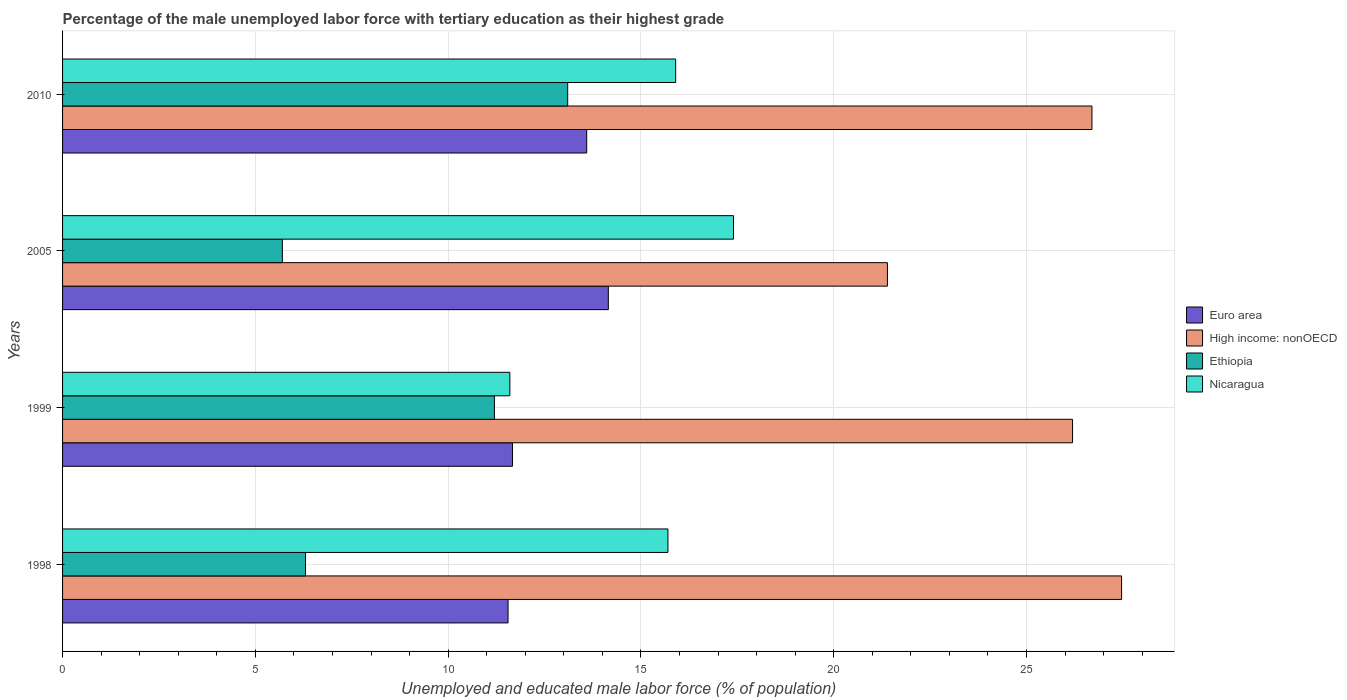How many different coloured bars are there?
Provide a succinct answer. 4. How many groups of bars are there?
Make the answer very short. 4. Are the number of bars per tick equal to the number of legend labels?
Your answer should be very brief. Yes. How many bars are there on the 1st tick from the top?
Provide a succinct answer. 4. In how many cases, is the number of bars for a given year not equal to the number of legend labels?
Offer a terse response. 0. What is the percentage of the unemployed male labor force with tertiary education in Euro area in 2010?
Your answer should be compact. 13.59. Across all years, what is the maximum percentage of the unemployed male labor force with tertiary education in Nicaragua?
Make the answer very short. 17.4. Across all years, what is the minimum percentage of the unemployed male labor force with tertiary education in Euro area?
Offer a very short reply. 11.55. In which year was the percentage of the unemployed male labor force with tertiary education in Ethiopia minimum?
Your answer should be very brief. 2005. What is the total percentage of the unemployed male labor force with tertiary education in High income: nonOECD in the graph?
Keep it short and to the point. 101.75. What is the difference between the percentage of the unemployed male labor force with tertiary education in Nicaragua in 1998 and that in 2010?
Ensure brevity in your answer.  -0.2. What is the difference between the percentage of the unemployed male labor force with tertiary education in High income: nonOECD in 1998 and the percentage of the unemployed male labor force with tertiary education in Euro area in 1999?
Your answer should be compact. 15.8. What is the average percentage of the unemployed male labor force with tertiary education in Euro area per year?
Your response must be concise. 12.74. In the year 1999, what is the difference between the percentage of the unemployed male labor force with tertiary education in Euro area and percentage of the unemployed male labor force with tertiary education in Nicaragua?
Keep it short and to the point. 0.07. What is the ratio of the percentage of the unemployed male labor force with tertiary education in Nicaragua in 1998 to that in 2010?
Offer a very short reply. 0.99. Is the difference between the percentage of the unemployed male labor force with tertiary education in Euro area in 1998 and 2005 greater than the difference between the percentage of the unemployed male labor force with tertiary education in Nicaragua in 1998 and 2005?
Your answer should be compact. No. What is the difference between the highest and the second highest percentage of the unemployed male labor force with tertiary education in Euro area?
Ensure brevity in your answer.  0.56. What is the difference between the highest and the lowest percentage of the unemployed male labor force with tertiary education in High income: nonOECD?
Ensure brevity in your answer.  6.07. In how many years, is the percentage of the unemployed male labor force with tertiary education in Nicaragua greater than the average percentage of the unemployed male labor force with tertiary education in Nicaragua taken over all years?
Your answer should be very brief. 3. Is the sum of the percentage of the unemployed male labor force with tertiary education in Euro area in 1998 and 2010 greater than the maximum percentage of the unemployed male labor force with tertiary education in High income: nonOECD across all years?
Your response must be concise. No. Is it the case that in every year, the sum of the percentage of the unemployed male labor force with tertiary education in Nicaragua and percentage of the unemployed male labor force with tertiary education in Euro area is greater than the sum of percentage of the unemployed male labor force with tertiary education in Ethiopia and percentage of the unemployed male labor force with tertiary education in High income: nonOECD?
Your response must be concise. No. What does the 1st bar from the top in 1999 represents?
Provide a succinct answer. Nicaragua. How many years are there in the graph?
Your answer should be very brief. 4. What is the difference between two consecutive major ticks on the X-axis?
Provide a short and direct response. 5. Are the values on the major ticks of X-axis written in scientific E-notation?
Make the answer very short. No. Does the graph contain any zero values?
Your answer should be compact. No. How are the legend labels stacked?
Offer a terse response. Vertical. What is the title of the graph?
Your response must be concise. Percentage of the male unemployed labor force with tertiary education as their highest grade. What is the label or title of the X-axis?
Your response must be concise. Unemployed and educated male labor force (% of population). What is the label or title of the Y-axis?
Your response must be concise. Years. What is the Unemployed and educated male labor force (% of population) of Euro area in 1998?
Offer a very short reply. 11.55. What is the Unemployed and educated male labor force (% of population) of High income: nonOECD in 1998?
Offer a very short reply. 27.46. What is the Unemployed and educated male labor force (% of population) in Ethiopia in 1998?
Keep it short and to the point. 6.3. What is the Unemployed and educated male labor force (% of population) in Nicaragua in 1998?
Offer a terse response. 15.7. What is the Unemployed and educated male labor force (% of population) of Euro area in 1999?
Keep it short and to the point. 11.67. What is the Unemployed and educated male labor force (% of population) of High income: nonOECD in 1999?
Ensure brevity in your answer.  26.19. What is the Unemployed and educated male labor force (% of population) of Ethiopia in 1999?
Make the answer very short. 11.2. What is the Unemployed and educated male labor force (% of population) of Nicaragua in 1999?
Give a very brief answer. 11.6. What is the Unemployed and educated male labor force (% of population) of Euro area in 2005?
Your response must be concise. 14.15. What is the Unemployed and educated male labor force (% of population) in High income: nonOECD in 2005?
Your answer should be very brief. 21.39. What is the Unemployed and educated male labor force (% of population) in Ethiopia in 2005?
Ensure brevity in your answer.  5.7. What is the Unemployed and educated male labor force (% of population) of Nicaragua in 2005?
Give a very brief answer. 17.4. What is the Unemployed and educated male labor force (% of population) of Euro area in 2010?
Keep it short and to the point. 13.59. What is the Unemployed and educated male labor force (% of population) of High income: nonOECD in 2010?
Your answer should be very brief. 26.7. What is the Unemployed and educated male labor force (% of population) of Ethiopia in 2010?
Make the answer very short. 13.1. What is the Unemployed and educated male labor force (% of population) of Nicaragua in 2010?
Your answer should be very brief. 15.9. Across all years, what is the maximum Unemployed and educated male labor force (% of population) of Euro area?
Offer a terse response. 14.15. Across all years, what is the maximum Unemployed and educated male labor force (% of population) in High income: nonOECD?
Keep it short and to the point. 27.46. Across all years, what is the maximum Unemployed and educated male labor force (% of population) in Ethiopia?
Your answer should be very brief. 13.1. Across all years, what is the maximum Unemployed and educated male labor force (% of population) in Nicaragua?
Offer a terse response. 17.4. Across all years, what is the minimum Unemployed and educated male labor force (% of population) of Euro area?
Make the answer very short. 11.55. Across all years, what is the minimum Unemployed and educated male labor force (% of population) of High income: nonOECD?
Keep it short and to the point. 21.39. Across all years, what is the minimum Unemployed and educated male labor force (% of population) in Ethiopia?
Offer a very short reply. 5.7. Across all years, what is the minimum Unemployed and educated male labor force (% of population) of Nicaragua?
Ensure brevity in your answer.  11.6. What is the total Unemployed and educated male labor force (% of population) in Euro area in the graph?
Offer a terse response. 50.97. What is the total Unemployed and educated male labor force (% of population) of High income: nonOECD in the graph?
Offer a terse response. 101.75. What is the total Unemployed and educated male labor force (% of population) of Ethiopia in the graph?
Offer a terse response. 36.3. What is the total Unemployed and educated male labor force (% of population) in Nicaragua in the graph?
Your answer should be compact. 60.6. What is the difference between the Unemployed and educated male labor force (% of population) in Euro area in 1998 and that in 1999?
Offer a terse response. -0.11. What is the difference between the Unemployed and educated male labor force (% of population) in High income: nonOECD in 1998 and that in 1999?
Make the answer very short. 1.27. What is the difference between the Unemployed and educated male labor force (% of population) of Ethiopia in 1998 and that in 1999?
Provide a succinct answer. -4.9. What is the difference between the Unemployed and educated male labor force (% of population) of Nicaragua in 1998 and that in 1999?
Provide a succinct answer. 4.1. What is the difference between the Unemployed and educated male labor force (% of population) of Euro area in 1998 and that in 2005?
Your answer should be compact. -2.6. What is the difference between the Unemployed and educated male labor force (% of population) in High income: nonOECD in 1998 and that in 2005?
Keep it short and to the point. 6.07. What is the difference between the Unemployed and educated male labor force (% of population) of Ethiopia in 1998 and that in 2005?
Provide a short and direct response. 0.6. What is the difference between the Unemployed and educated male labor force (% of population) of Nicaragua in 1998 and that in 2005?
Your answer should be very brief. -1.7. What is the difference between the Unemployed and educated male labor force (% of population) in Euro area in 1998 and that in 2010?
Ensure brevity in your answer.  -2.04. What is the difference between the Unemployed and educated male labor force (% of population) in High income: nonOECD in 1998 and that in 2010?
Offer a very short reply. 0.77. What is the difference between the Unemployed and educated male labor force (% of population) of Ethiopia in 1998 and that in 2010?
Your answer should be compact. -6.8. What is the difference between the Unemployed and educated male labor force (% of population) of Nicaragua in 1998 and that in 2010?
Ensure brevity in your answer.  -0.2. What is the difference between the Unemployed and educated male labor force (% of population) of Euro area in 1999 and that in 2005?
Keep it short and to the point. -2.49. What is the difference between the Unemployed and educated male labor force (% of population) of High income: nonOECD in 1999 and that in 2005?
Ensure brevity in your answer.  4.8. What is the difference between the Unemployed and educated male labor force (% of population) in Ethiopia in 1999 and that in 2005?
Offer a terse response. 5.5. What is the difference between the Unemployed and educated male labor force (% of population) in Nicaragua in 1999 and that in 2005?
Ensure brevity in your answer.  -5.8. What is the difference between the Unemployed and educated male labor force (% of population) of Euro area in 1999 and that in 2010?
Your response must be concise. -1.93. What is the difference between the Unemployed and educated male labor force (% of population) in High income: nonOECD in 1999 and that in 2010?
Your response must be concise. -0.5. What is the difference between the Unemployed and educated male labor force (% of population) of Ethiopia in 1999 and that in 2010?
Ensure brevity in your answer.  -1.9. What is the difference between the Unemployed and educated male labor force (% of population) in Nicaragua in 1999 and that in 2010?
Your response must be concise. -4.3. What is the difference between the Unemployed and educated male labor force (% of population) in Euro area in 2005 and that in 2010?
Your response must be concise. 0.56. What is the difference between the Unemployed and educated male labor force (% of population) of High income: nonOECD in 2005 and that in 2010?
Keep it short and to the point. -5.3. What is the difference between the Unemployed and educated male labor force (% of population) in Nicaragua in 2005 and that in 2010?
Your answer should be compact. 1.5. What is the difference between the Unemployed and educated male labor force (% of population) in Euro area in 1998 and the Unemployed and educated male labor force (% of population) in High income: nonOECD in 1999?
Ensure brevity in your answer.  -14.64. What is the difference between the Unemployed and educated male labor force (% of population) of Euro area in 1998 and the Unemployed and educated male labor force (% of population) of Ethiopia in 1999?
Ensure brevity in your answer.  0.35. What is the difference between the Unemployed and educated male labor force (% of population) of Euro area in 1998 and the Unemployed and educated male labor force (% of population) of Nicaragua in 1999?
Give a very brief answer. -0.05. What is the difference between the Unemployed and educated male labor force (% of population) in High income: nonOECD in 1998 and the Unemployed and educated male labor force (% of population) in Ethiopia in 1999?
Offer a very short reply. 16.26. What is the difference between the Unemployed and educated male labor force (% of population) of High income: nonOECD in 1998 and the Unemployed and educated male labor force (% of population) of Nicaragua in 1999?
Provide a succinct answer. 15.86. What is the difference between the Unemployed and educated male labor force (% of population) of Ethiopia in 1998 and the Unemployed and educated male labor force (% of population) of Nicaragua in 1999?
Keep it short and to the point. -5.3. What is the difference between the Unemployed and educated male labor force (% of population) in Euro area in 1998 and the Unemployed and educated male labor force (% of population) in High income: nonOECD in 2005?
Offer a terse response. -9.84. What is the difference between the Unemployed and educated male labor force (% of population) in Euro area in 1998 and the Unemployed and educated male labor force (% of population) in Ethiopia in 2005?
Keep it short and to the point. 5.85. What is the difference between the Unemployed and educated male labor force (% of population) in Euro area in 1998 and the Unemployed and educated male labor force (% of population) in Nicaragua in 2005?
Keep it short and to the point. -5.85. What is the difference between the Unemployed and educated male labor force (% of population) of High income: nonOECD in 1998 and the Unemployed and educated male labor force (% of population) of Ethiopia in 2005?
Your answer should be very brief. 21.76. What is the difference between the Unemployed and educated male labor force (% of population) in High income: nonOECD in 1998 and the Unemployed and educated male labor force (% of population) in Nicaragua in 2005?
Ensure brevity in your answer.  10.06. What is the difference between the Unemployed and educated male labor force (% of population) in Euro area in 1998 and the Unemployed and educated male labor force (% of population) in High income: nonOECD in 2010?
Provide a short and direct response. -15.14. What is the difference between the Unemployed and educated male labor force (% of population) in Euro area in 1998 and the Unemployed and educated male labor force (% of population) in Ethiopia in 2010?
Your answer should be compact. -1.55. What is the difference between the Unemployed and educated male labor force (% of population) of Euro area in 1998 and the Unemployed and educated male labor force (% of population) of Nicaragua in 2010?
Make the answer very short. -4.35. What is the difference between the Unemployed and educated male labor force (% of population) in High income: nonOECD in 1998 and the Unemployed and educated male labor force (% of population) in Ethiopia in 2010?
Offer a terse response. 14.36. What is the difference between the Unemployed and educated male labor force (% of population) of High income: nonOECD in 1998 and the Unemployed and educated male labor force (% of population) of Nicaragua in 2010?
Give a very brief answer. 11.56. What is the difference between the Unemployed and educated male labor force (% of population) in Euro area in 1999 and the Unemployed and educated male labor force (% of population) in High income: nonOECD in 2005?
Your answer should be compact. -9.72. What is the difference between the Unemployed and educated male labor force (% of population) in Euro area in 1999 and the Unemployed and educated male labor force (% of population) in Ethiopia in 2005?
Your response must be concise. 5.97. What is the difference between the Unemployed and educated male labor force (% of population) of Euro area in 1999 and the Unemployed and educated male labor force (% of population) of Nicaragua in 2005?
Provide a short and direct response. -5.73. What is the difference between the Unemployed and educated male labor force (% of population) in High income: nonOECD in 1999 and the Unemployed and educated male labor force (% of population) in Ethiopia in 2005?
Ensure brevity in your answer.  20.49. What is the difference between the Unemployed and educated male labor force (% of population) of High income: nonOECD in 1999 and the Unemployed and educated male labor force (% of population) of Nicaragua in 2005?
Ensure brevity in your answer.  8.79. What is the difference between the Unemployed and educated male labor force (% of population) of Euro area in 1999 and the Unemployed and educated male labor force (% of population) of High income: nonOECD in 2010?
Provide a short and direct response. -15.03. What is the difference between the Unemployed and educated male labor force (% of population) in Euro area in 1999 and the Unemployed and educated male labor force (% of population) in Ethiopia in 2010?
Make the answer very short. -1.43. What is the difference between the Unemployed and educated male labor force (% of population) of Euro area in 1999 and the Unemployed and educated male labor force (% of population) of Nicaragua in 2010?
Give a very brief answer. -4.23. What is the difference between the Unemployed and educated male labor force (% of population) in High income: nonOECD in 1999 and the Unemployed and educated male labor force (% of population) in Ethiopia in 2010?
Give a very brief answer. 13.09. What is the difference between the Unemployed and educated male labor force (% of population) in High income: nonOECD in 1999 and the Unemployed and educated male labor force (% of population) in Nicaragua in 2010?
Provide a short and direct response. 10.29. What is the difference between the Unemployed and educated male labor force (% of population) of Euro area in 2005 and the Unemployed and educated male labor force (% of population) of High income: nonOECD in 2010?
Offer a terse response. -12.54. What is the difference between the Unemployed and educated male labor force (% of population) of Euro area in 2005 and the Unemployed and educated male labor force (% of population) of Ethiopia in 2010?
Ensure brevity in your answer.  1.05. What is the difference between the Unemployed and educated male labor force (% of population) in Euro area in 2005 and the Unemployed and educated male labor force (% of population) in Nicaragua in 2010?
Give a very brief answer. -1.75. What is the difference between the Unemployed and educated male labor force (% of population) in High income: nonOECD in 2005 and the Unemployed and educated male labor force (% of population) in Ethiopia in 2010?
Provide a succinct answer. 8.29. What is the difference between the Unemployed and educated male labor force (% of population) in High income: nonOECD in 2005 and the Unemployed and educated male labor force (% of population) in Nicaragua in 2010?
Give a very brief answer. 5.49. What is the average Unemployed and educated male labor force (% of population) of Euro area per year?
Your answer should be very brief. 12.74. What is the average Unemployed and educated male labor force (% of population) in High income: nonOECD per year?
Provide a short and direct response. 25.44. What is the average Unemployed and educated male labor force (% of population) in Ethiopia per year?
Ensure brevity in your answer.  9.07. What is the average Unemployed and educated male labor force (% of population) in Nicaragua per year?
Ensure brevity in your answer.  15.15. In the year 1998, what is the difference between the Unemployed and educated male labor force (% of population) in Euro area and Unemployed and educated male labor force (% of population) in High income: nonOECD?
Your answer should be very brief. -15.91. In the year 1998, what is the difference between the Unemployed and educated male labor force (% of population) of Euro area and Unemployed and educated male labor force (% of population) of Ethiopia?
Give a very brief answer. 5.25. In the year 1998, what is the difference between the Unemployed and educated male labor force (% of population) in Euro area and Unemployed and educated male labor force (% of population) in Nicaragua?
Your response must be concise. -4.15. In the year 1998, what is the difference between the Unemployed and educated male labor force (% of population) in High income: nonOECD and Unemployed and educated male labor force (% of population) in Ethiopia?
Give a very brief answer. 21.16. In the year 1998, what is the difference between the Unemployed and educated male labor force (% of population) of High income: nonOECD and Unemployed and educated male labor force (% of population) of Nicaragua?
Provide a short and direct response. 11.76. In the year 1999, what is the difference between the Unemployed and educated male labor force (% of population) of Euro area and Unemployed and educated male labor force (% of population) of High income: nonOECD?
Offer a terse response. -14.53. In the year 1999, what is the difference between the Unemployed and educated male labor force (% of population) of Euro area and Unemployed and educated male labor force (% of population) of Ethiopia?
Offer a terse response. 0.47. In the year 1999, what is the difference between the Unemployed and educated male labor force (% of population) of Euro area and Unemployed and educated male labor force (% of population) of Nicaragua?
Make the answer very short. 0.07. In the year 1999, what is the difference between the Unemployed and educated male labor force (% of population) of High income: nonOECD and Unemployed and educated male labor force (% of population) of Ethiopia?
Give a very brief answer. 14.99. In the year 1999, what is the difference between the Unemployed and educated male labor force (% of population) in High income: nonOECD and Unemployed and educated male labor force (% of population) in Nicaragua?
Your answer should be compact. 14.59. In the year 1999, what is the difference between the Unemployed and educated male labor force (% of population) in Ethiopia and Unemployed and educated male labor force (% of population) in Nicaragua?
Your response must be concise. -0.4. In the year 2005, what is the difference between the Unemployed and educated male labor force (% of population) of Euro area and Unemployed and educated male labor force (% of population) of High income: nonOECD?
Ensure brevity in your answer.  -7.24. In the year 2005, what is the difference between the Unemployed and educated male labor force (% of population) of Euro area and Unemployed and educated male labor force (% of population) of Ethiopia?
Make the answer very short. 8.45. In the year 2005, what is the difference between the Unemployed and educated male labor force (% of population) of Euro area and Unemployed and educated male labor force (% of population) of Nicaragua?
Provide a succinct answer. -3.25. In the year 2005, what is the difference between the Unemployed and educated male labor force (% of population) of High income: nonOECD and Unemployed and educated male labor force (% of population) of Ethiopia?
Offer a terse response. 15.69. In the year 2005, what is the difference between the Unemployed and educated male labor force (% of population) in High income: nonOECD and Unemployed and educated male labor force (% of population) in Nicaragua?
Ensure brevity in your answer.  3.99. In the year 2005, what is the difference between the Unemployed and educated male labor force (% of population) in Ethiopia and Unemployed and educated male labor force (% of population) in Nicaragua?
Make the answer very short. -11.7. In the year 2010, what is the difference between the Unemployed and educated male labor force (% of population) of Euro area and Unemployed and educated male labor force (% of population) of High income: nonOECD?
Provide a short and direct response. -13.1. In the year 2010, what is the difference between the Unemployed and educated male labor force (% of population) in Euro area and Unemployed and educated male labor force (% of population) in Ethiopia?
Provide a succinct answer. 0.49. In the year 2010, what is the difference between the Unemployed and educated male labor force (% of population) of Euro area and Unemployed and educated male labor force (% of population) of Nicaragua?
Offer a very short reply. -2.31. In the year 2010, what is the difference between the Unemployed and educated male labor force (% of population) of High income: nonOECD and Unemployed and educated male labor force (% of population) of Ethiopia?
Provide a short and direct response. 13.6. In the year 2010, what is the difference between the Unemployed and educated male labor force (% of population) in High income: nonOECD and Unemployed and educated male labor force (% of population) in Nicaragua?
Offer a very short reply. 10.8. What is the ratio of the Unemployed and educated male labor force (% of population) in Euro area in 1998 to that in 1999?
Your response must be concise. 0.99. What is the ratio of the Unemployed and educated male labor force (% of population) of High income: nonOECD in 1998 to that in 1999?
Your answer should be very brief. 1.05. What is the ratio of the Unemployed and educated male labor force (% of population) in Ethiopia in 1998 to that in 1999?
Your response must be concise. 0.56. What is the ratio of the Unemployed and educated male labor force (% of population) in Nicaragua in 1998 to that in 1999?
Offer a terse response. 1.35. What is the ratio of the Unemployed and educated male labor force (% of population) of Euro area in 1998 to that in 2005?
Offer a terse response. 0.82. What is the ratio of the Unemployed and educated male labor force (% of population) in High income: nonOECD in 1998 to that in 2005?
Provide a short and direct response. 1.28. What is the ratio of the Unemployed and educated male labor force (% of population) of Ethiopia in 1998 to that in 2005?
Keep it short and to the point. 1.11. What is the ratio of the Unemployed and educated male labor force (% of population) of Nicaragua in 1998 to that in 2005?
Offer a terse response. 0.9. What is the ratio of the Unemployed and educated male labor force (% of population) of Euro area in 1998 to that in 2010?
Keep it short and to the point. 0.85. What is the ratio of the Unemployed and educated male labor force (% of population) in High income: nonOECD in 1998 to that in 2010?
Your answer should be compact. 1.03. What is the ratio of the Unemployed and educated male labor force (% of population) of Ethiopia in 1998 to that in 2010?
Your answer should be very brief. 0.48. What is the ratio of the Unemployed and educated male labor force (% of population) of Nicaragua in 1998 to that in 2010?
Give a very brief answer. 0.99. What is the ratio of the Unemployed and educated male labor force (% of population) in Euro area in 1999 to that in 2005?
Your answer should be compact. 0.82. What is the ratio of the Unemployed and educated male labor force (% of population) of High income: nonOECD in 1999 to that in 2005?
Your response must be concise. 1.22. What is the ratio of the Unemployed and educated male labor force (% of population) of Ethiopia in 1999 to that in 2005?
Provide a short and direct response. 1.96. What is the ratio of the Unemployed and educated male labor force (% of population) in Euro area in 1999 to that in 2010?
Make the answer very short. 0.86. What is the ratio of the Unemployed and educated male labor force (% of population) in High income: nonOECD in 1999 to that in 2010?
Give a very brief answer. 0.98. What is the ratio of the Unemployed and educated male labor force (% of population) in Ethiopia in 1999 to that in 2010?
Make the answer very short. 0.85. What is the ratio of the Unemployed and educated male labor force (% of population) of Nicaragua in 1999 to that in 2010?
Your answer should be very brief. 0.73. What is the ratio of the Unemployed and educated male labor force (% of population) in Euro area in 2005 to that in 2010?
Offer a very short reply. 1.04. What is the ratio of the Unemployed and educated male labor force (% of population) in High income: nonOECD in 2005 to that in 2010?
Provide a succinct answer. 0.8. What is the ratio of the Unemployed and educated male labor force (% of population) of Ethiopia in 2005 to that in 2010?
Offer a very short reply. 0.44. What is the ratio of the Unemployed and educated male labor force (% of population) of Nicaragua in 2005 to that in 2010?
Offer a very short reply. 1.09. What is the difference between the highest and the second highest Unemployed and educated male labor force (% of population) of Euro area?
Your response must be concise. 0.56. What is the difference between the highest and the second highest Unemployed and educated male labor force (% of population) in High income: nonOECD?
Offer a terse response. 0.77. What is the difference between the highest and the second highest Unemployed and educated male labor force (% of population) of Ethiopia?
Provide a succinct answer. 1.9. What is the difference between the highest and the second highest Unemployed and educated male labor force (% of population) in Nicaragua?
Provide a succinct answer. 1.5. What is the difference between the highest and the lowest Unemployed and educated male labor force (% of population) in Euro area?
Your answer should be very brief. 2.6. What is the difference between the highest and the lowest Unemployed and educated male labor force (% of population) of High income: nonOECD?
Ensure brevity in your answer.  6.07. What is the difference between the highest and the lowest Unemployed and educated male labor force (% of population) in Ethiopia?
Provide a succinct answer. 7.4. 